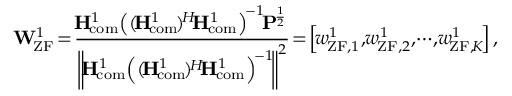<formula> <loc_0><loc_0><loc_500><loc_500>{ \, { W } _ { \, Z F } ^ { 1 } } \, = \, \frac { { \, { { H } _ { \, { c o m } } ^ { 1 } } { { \left ( { ( \, { { H } _ { \, { c o m } } ^ { 1 } } \, ) ^ { \, H } { \, { H } _ { \, { c o m } } ^ { 1 } } } \right ) } ^ { \, - 1 } } { \, { P } ^ { \, \frac { 1 } { 2 } } } } } { { { { \left \| \, { { H } _ { \, { c o m } } ^ { 1 } } { { \left ( { ( \, { { H } _ { \, { c o m } } ^ { 1 } } \, ) ^ { \, H } { \, { H } _ { \, { c o m } } ^ { 1 } } } \right ) } ^ { \, - 1 } } \, \right \| } ^ { 2 } } } } \, = \, \left [ { \, { w } _ { \, { Z F } , 1 } ^ { 1 } } , { \, { w } _ { \, { Z F } , 2 } ^ { 1 } } , \, \cdots \, , { \, { w } _ { \, { Z F } , \, K } ^ { 1 } } \, \right ] ,</formula> 